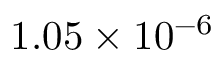<formula> <loc_0><loc_0><loc_500><loc_500>1 . 0 5 \times 1 0 ^ { - 6 }</formula> 